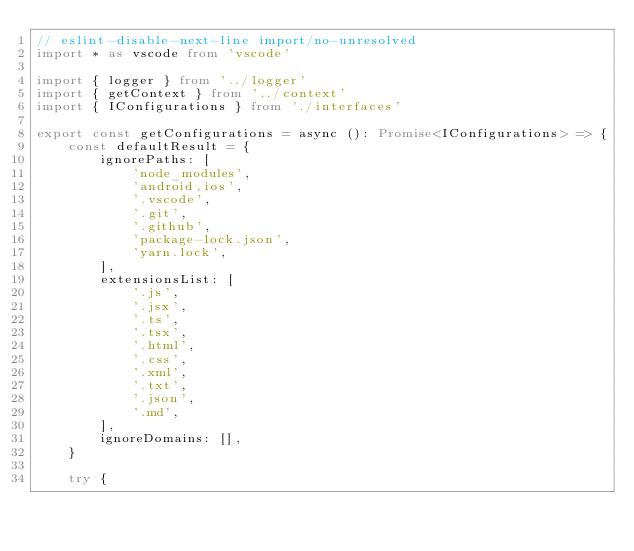<code> <loc_0><loc_0><loc_500><loc_500><_TypeScript_>// eslint-disable-next-line import/no-unresolved
import * as vscode from 'vscode'

import { logger } from '../logger'
import { getContext } from '../context'
import { IConfigurations } from './interfaces'

export const getConfigurations = async (): Promise<IConfigurations> => {
    const defaultResult = {
        ignorePaths: [
            'node_modules',
            'android,ios',
            '.vscode',
            '.git',
            '.github',
            'package-lock.json',
            'yarn.lock',
        ],
        extensionsList: [
            '.js',
            '.jsx',
            '.ts',
            '.tsx',
            '.html',
            '.css',
            '.xml',
            '.txt',
            '.json',
            '.md',
        ],
        ignoreDomains: [],
    }

    try {</code> 